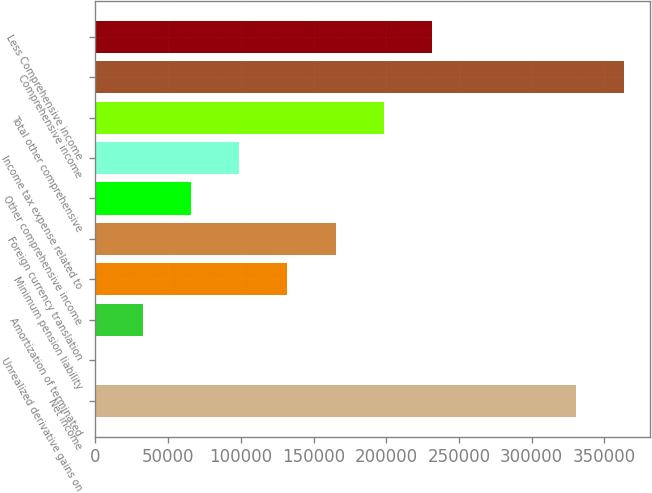<chart> <loc_0><loc_0><loc_500><loc_500><bar_chart><fcel>Net income<fcel>Unrealized derivative gains on<fcel>Amortization of terminated<fcel>Minimum pension liability<fcel>Foreign currency translation<fcel>Other comprehensive income<fcel>Income tax expense related to<fcel>Total other comprehensive<fcel>Comprehensive income<fcel>Less Comprehensive income<nl><fcel>330278<fcel>0.43<fcel>33028.2<fcel>132111<fcel>165139<fcel>66055.9<fcel>99083.7<fcel>198167<fcel>363306<fcel>231195<nl></chart> 